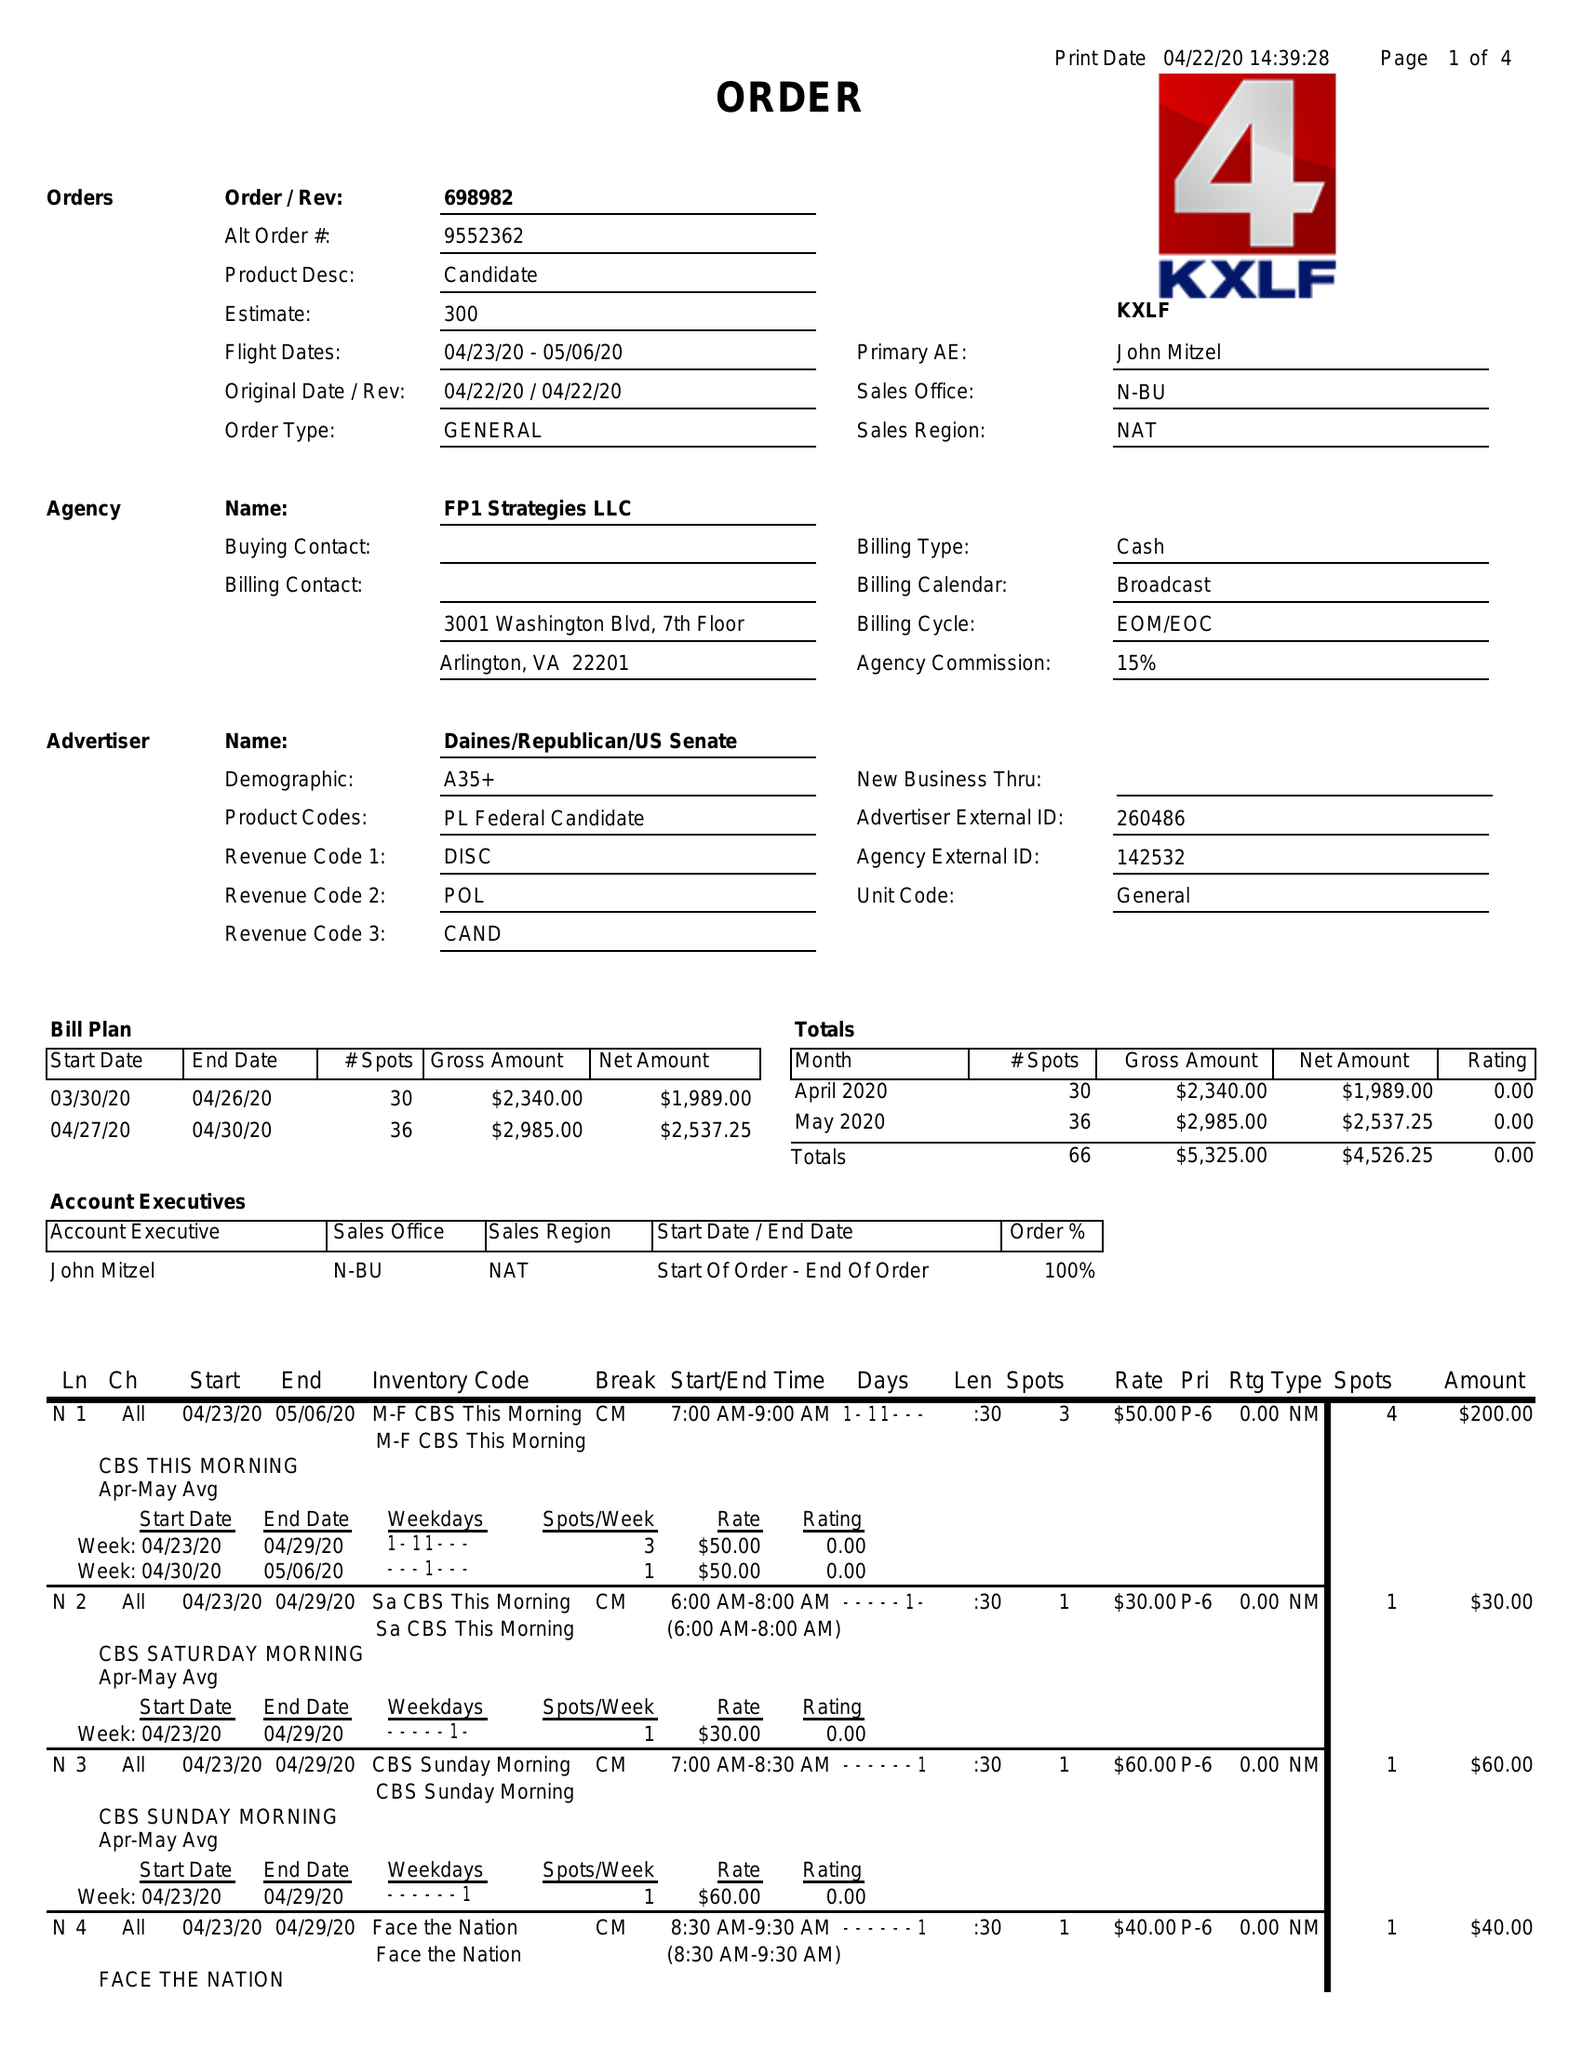What is the value for the flight_to?
Answer the question using a single word or phrase. 05/06/20 